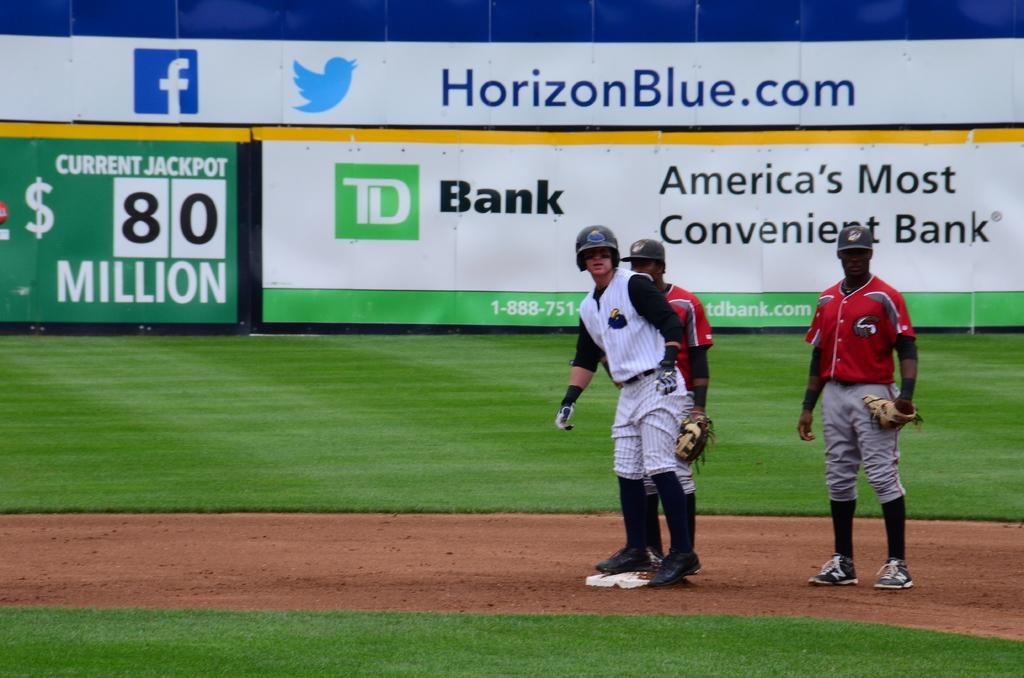<image>
Provide a brief description of the given image. Baseball players in a stadium with a Horizon Blue advertisement banner. 